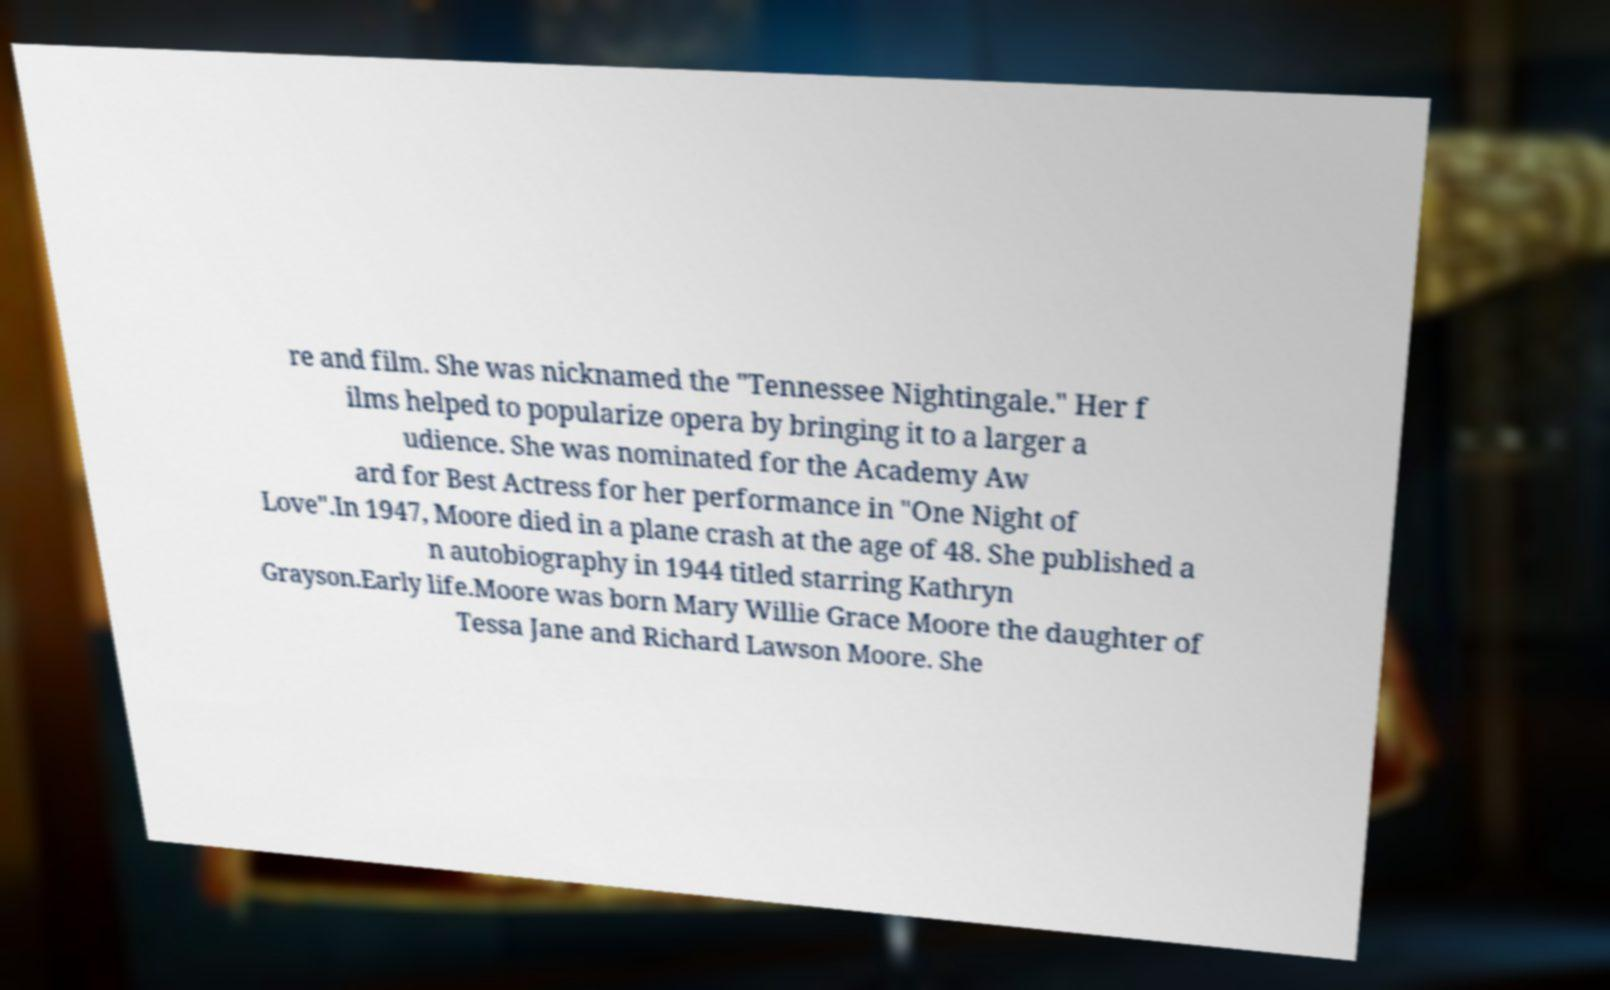I need the written content from this picture converted into text. Can you do that? re and film. She was nicknamed the "Tennessee Nightingale." Her f ilms helped to popularize opera by bringing it to a larger a udience. She was nominated for the Academy Aw ard for Best Actress for her performance in "One Night of Love".In 1947, Moore died in a plane crash at the age of 48. She published a n autobiography in 1944 titled starring Kathryn Grayson.Early life.Moore was born Mary Willie Grace Moore the daughter of Tessa Jane and Richard Lawson Moore. She 